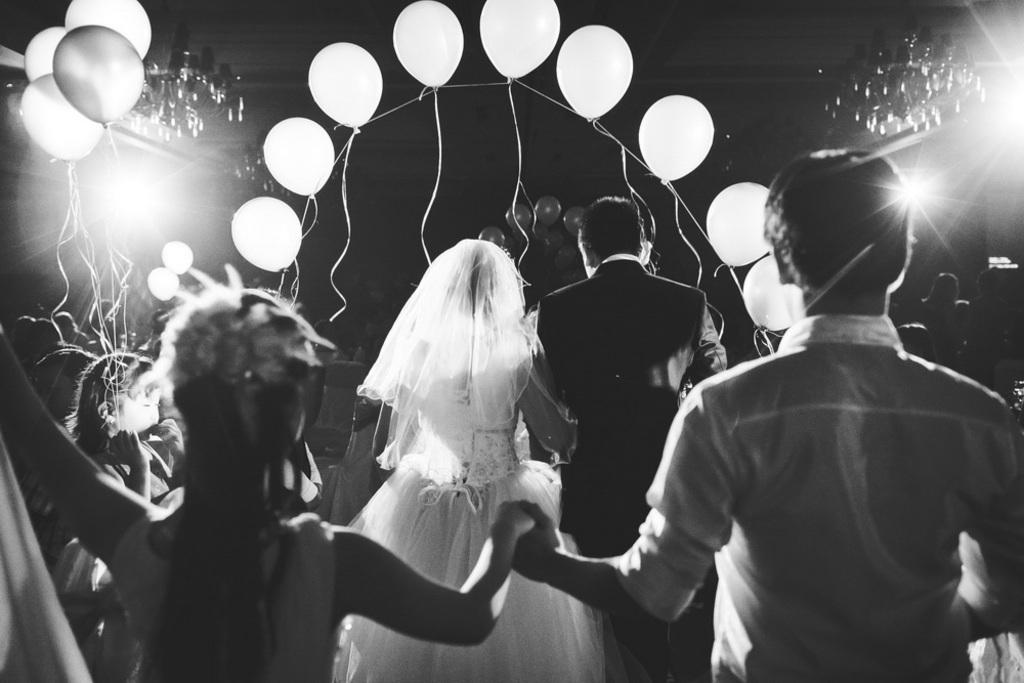What is the color scheme of the image? The image is black and white. What can be seen in the image besides the color scheme? There are persons and balloons in the image. What type of lighting is present in the image? There are ceiling lights in the image. How would you describe the overall appearance of the image? The background of the image is dark. Can you tell me how many cars are stuck in the quicksand in the image? There is no quicksand or cars present in the image. What type of ear is visible on the person in the image? There is no ear visible in the image, as the persons are not shown in detail. 